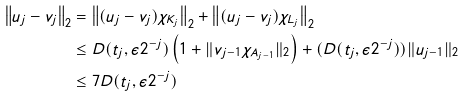<formula> <loc_0><loc_0><loc_500><loc_500>\left \| u _ { j } - v _ { j } \right \| _ { 2 } & = \left \| ( u _ { j } - v _ { j } ) \chi _ { K _ { j } } \right \| _ { 2 } + \left \| ( u _ { j } - v _ { j } ) \chi _ { L _ { j } } \right \| _ { 2 } \\ & \leq D ( t _ { j } , \epsilon 2 ^ { - j } ) \left ( 1 + \| v _ { j - 1 } \chi _ { A _ { j - 1 } } \| _ { 2 } \right ) + ( D ( t _ { j } , \epsilon 2 ^ { - j } ) ) \| u _ { j - 1 } \| _ { 2 } \\ & \leq 7 D ( t _ { j } , \epsilon 2 ^ { - j } )</formula> 